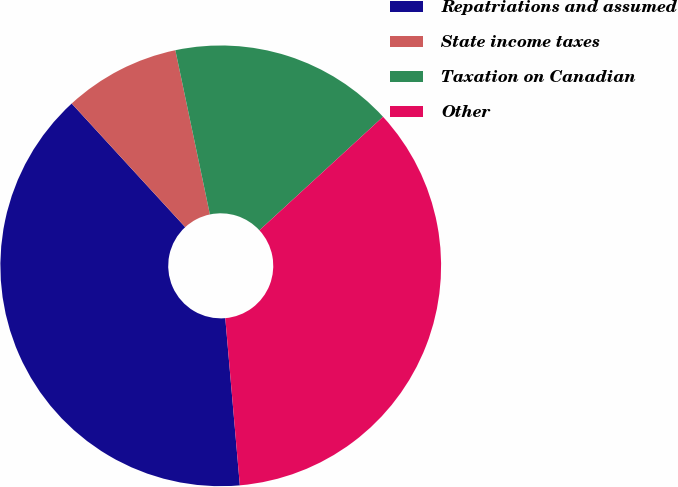<chart> <loc_0><loc_0><loc_500><loc_500><pie_chart><fcel>Repatriations and assumed<fcel>State income taxes<fcel>Taxation on Canadian<fcel>Other<nl><fcel>39.56%<fcel>8.52%<fcel>16.48%<fcel>35.44%<nl></chart> 